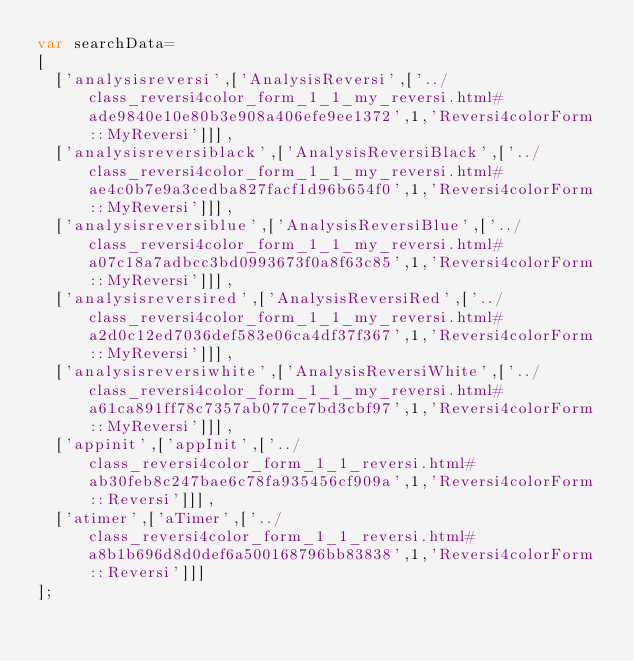<code> <loc_0><loc_0><loc_500><loc_500><_JavaScript_>var searchData=
[
  ['analysisreversi',['AnalysisReversi',['../class_reversi4color_form_1_1_my_reversi.html#ade9840e10e80b3e908a406efe9ee1372',1,'Reversi4colorForm::MyReversi']]],
  ['analysisreversiblack',['AnalysisReversiBlack',['../class_reversi4color_form_1_1_my_reversi.html#ae4c0b7e9a3cedba827facf1d96b654f0',1,'Reversi4colorForm::MyReversi']]],
  ['analysisreversiblue',['AnalysisReversiBlue',['../class_reversi4color_form_1_1_my_reversi.html#a07c18a7adbcc3bd0993673f0a8f63c85',1,'Reversi4colorForm::MyReversi']]],
  ['analysisreversired',['AnalysisReversiRed',['../class_reversi4color_form_1_1_my_reversi.html#a2d0c12ed7036def583e06ca4df37f367',1,'Reversi4colorForm::MyReversi']]],
  ['analysisreversiwhite',['AnalysisReversiWhite',['../class_reversi4color_form_1_1_my_reversi.html#a61ca891ff78c7357ab077ce7bd3cbf97',1,'Reversi4colorForm::MyReversi']]],
  ['appinit',['appInit',['../class_reversi4color_form_1_1_reversi.html#ab30feb8c247bae6c78fa935456cf909a',1,'Reversi4colorForm::Reversi']]],
  ['atimer',['aTimer',['../class_reversi4color_form_1_1_reversi.html#a8b1b696d8d0def6a500168796bb83838',1,'Reversi4colorForm::Reversi']]]
];
</code> 